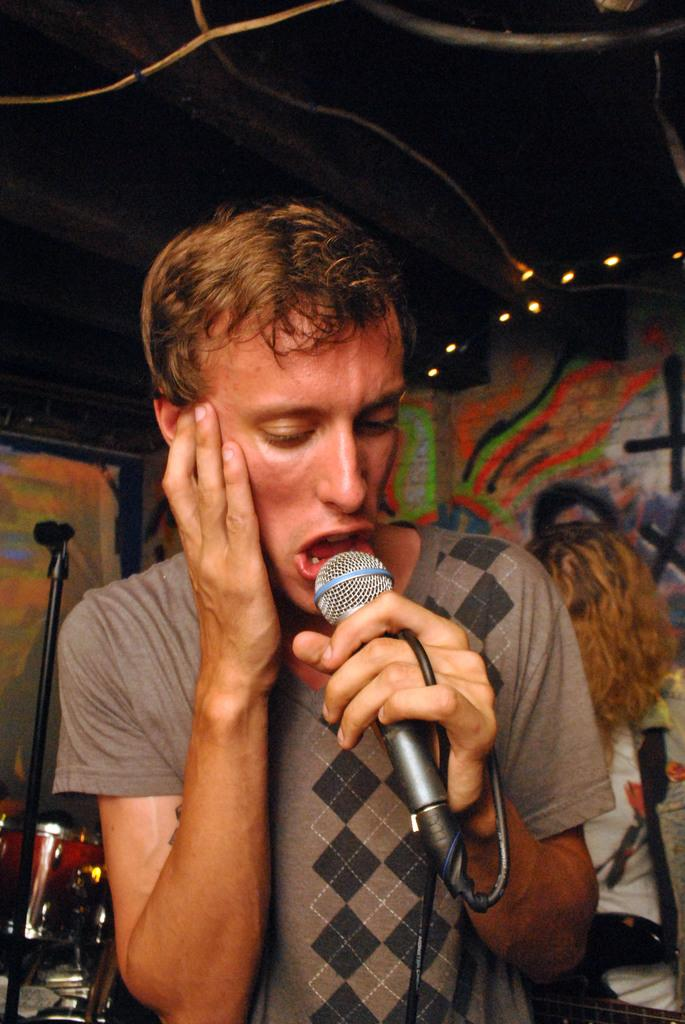What is the man in the image doing? The man is singing in the image. What object is the man holding in the image? The man is holding a microphone in the image. What musical instrument can be seen in the image? There are drums in the image. What type of background is visible in the image? There is a painted wall in the image. What can be seen providing illumination in the image? There are lights in the image. What type of steam is coming from the man's mouth while he sings in the image? There is no steam coming from the man's mouth in the image. What topic is the man discussing with the audience in the image? The man is singing, not discussing a topic, in the image. 